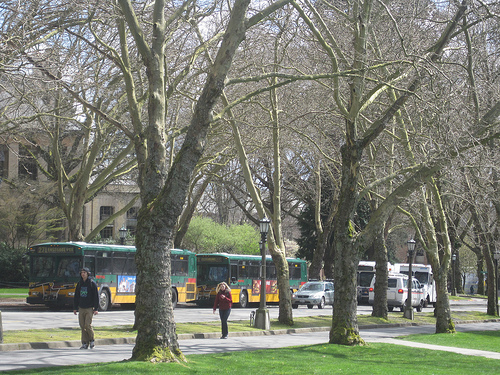Can you tell me about the buses in the background? Certainly, there are several buses captured in the background, lined up along the street. These buses sport a vibrant yellow color possibly indicative of a public transit system serving a metropolitan area. It suggests a bustling city life where the public transportation plays a pivotal role in daily commuting. 